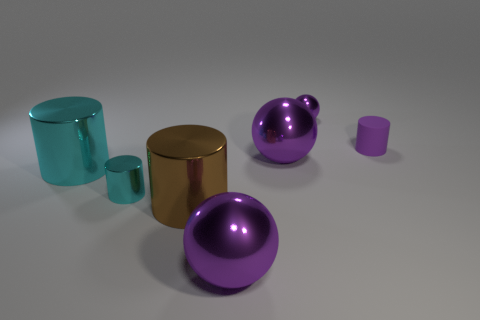What material is the small thing that is the same color as the small shiny ball?
Offer a very short reply. Rubber. Is there anything else that has the same shape as the big brown shiny object?
Keep it short and to the point. Yes. What number of things are either purple objects in front of the rubber thing or cyan metallic objects?
Keep it short and to the point. 4. There is a object behind the small matte cylinder; does it have the same color as the rubber cylinder?
Keep it short and to the point. Yes. There is a thing that is in front of the brown metal cylinder in front of the tiny purple cylinder; what shape is it?
Give a very brief answer. Sphere. Is the number of brown shiny cylinders behind the tiny purple matte cylinder less than the number of tiny things that are behind the brown thing?
Keep it short and to the point. Yes. What is the size of the purple matte thing that is the same shape as the brown thing?
Give a very brief answer. Small. Is there any other thing that is the same size as the brown thing?
Give a very brief answer. Yes. What number of things are cylinders in front of the matte cylinder or cylinders that are on the right side of the small cyan object?
Provide a succinct answer. 4. Is the size of the purple rubber thing the same as the brown object?
Keep it short and to the point. No. 